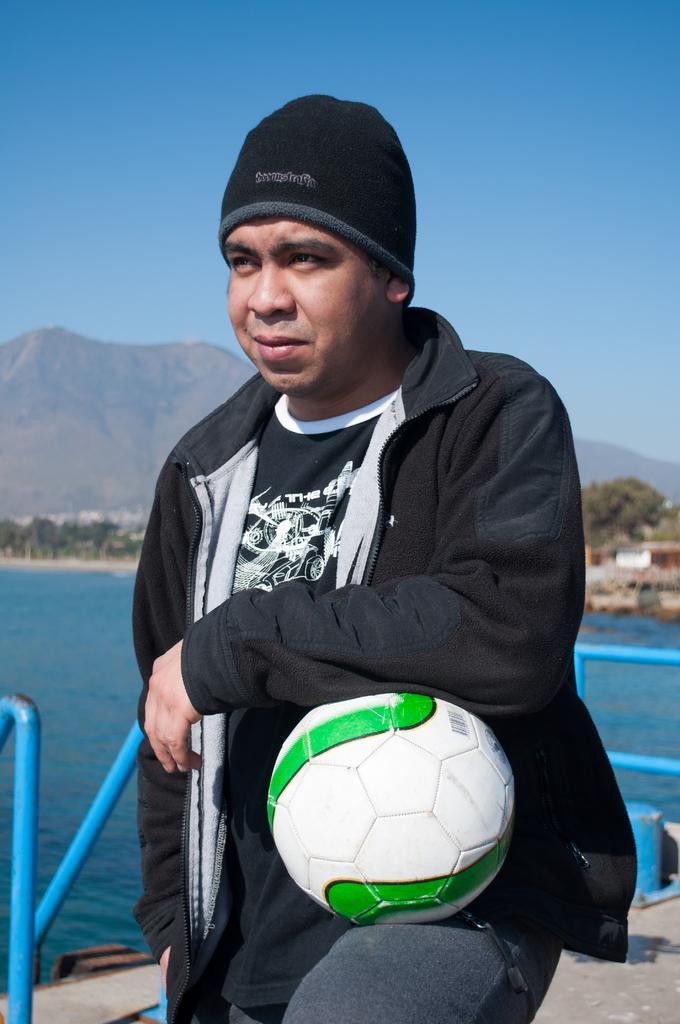Please provide a concise description of this image. In this image I can see a person holding the ball. In the background there is a water,mountains and the sky. 